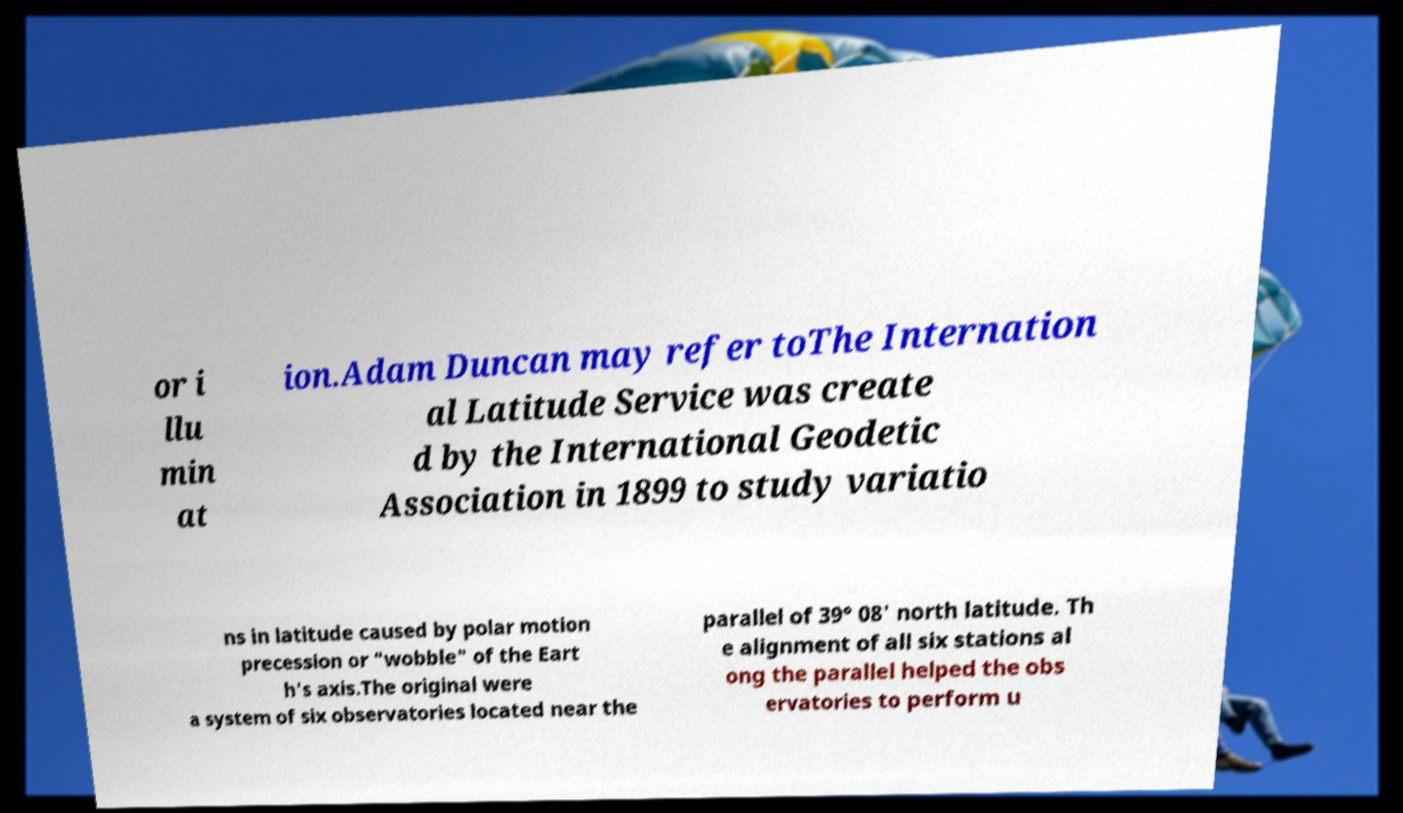Please read and relay the text visible in this image. What does it say? or i llu min at ion.Adam Duncan may refer toThe Internation al Latitude Service was create d by the International Geodetic Association in 1899 to study variatio ns in latitude caused by polar motion precession or "wobble" of the Eart h's axis.The original were a system of six observatories located near the parallel of 39° 08' north latitude. Th e alignment of all six stations al ong the parallel helped the obs ervatories to perform u 